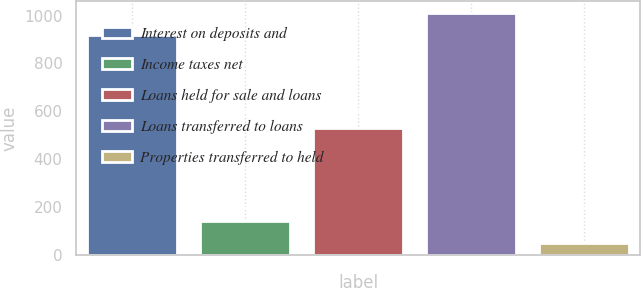<chart> <loc_0><loc_0><loc_500><loc_500><bar_chart><fcel>Interest on deposits and<fcel>Income taxes net<fcel>Loans held for sale and loans<fcel>Loans transferred to loans<fcel>Properties transferred to held<nl><fcel>919<fcel>143.2<fcel>532<fcel>1011.2<fcel>51<nl></chart> 